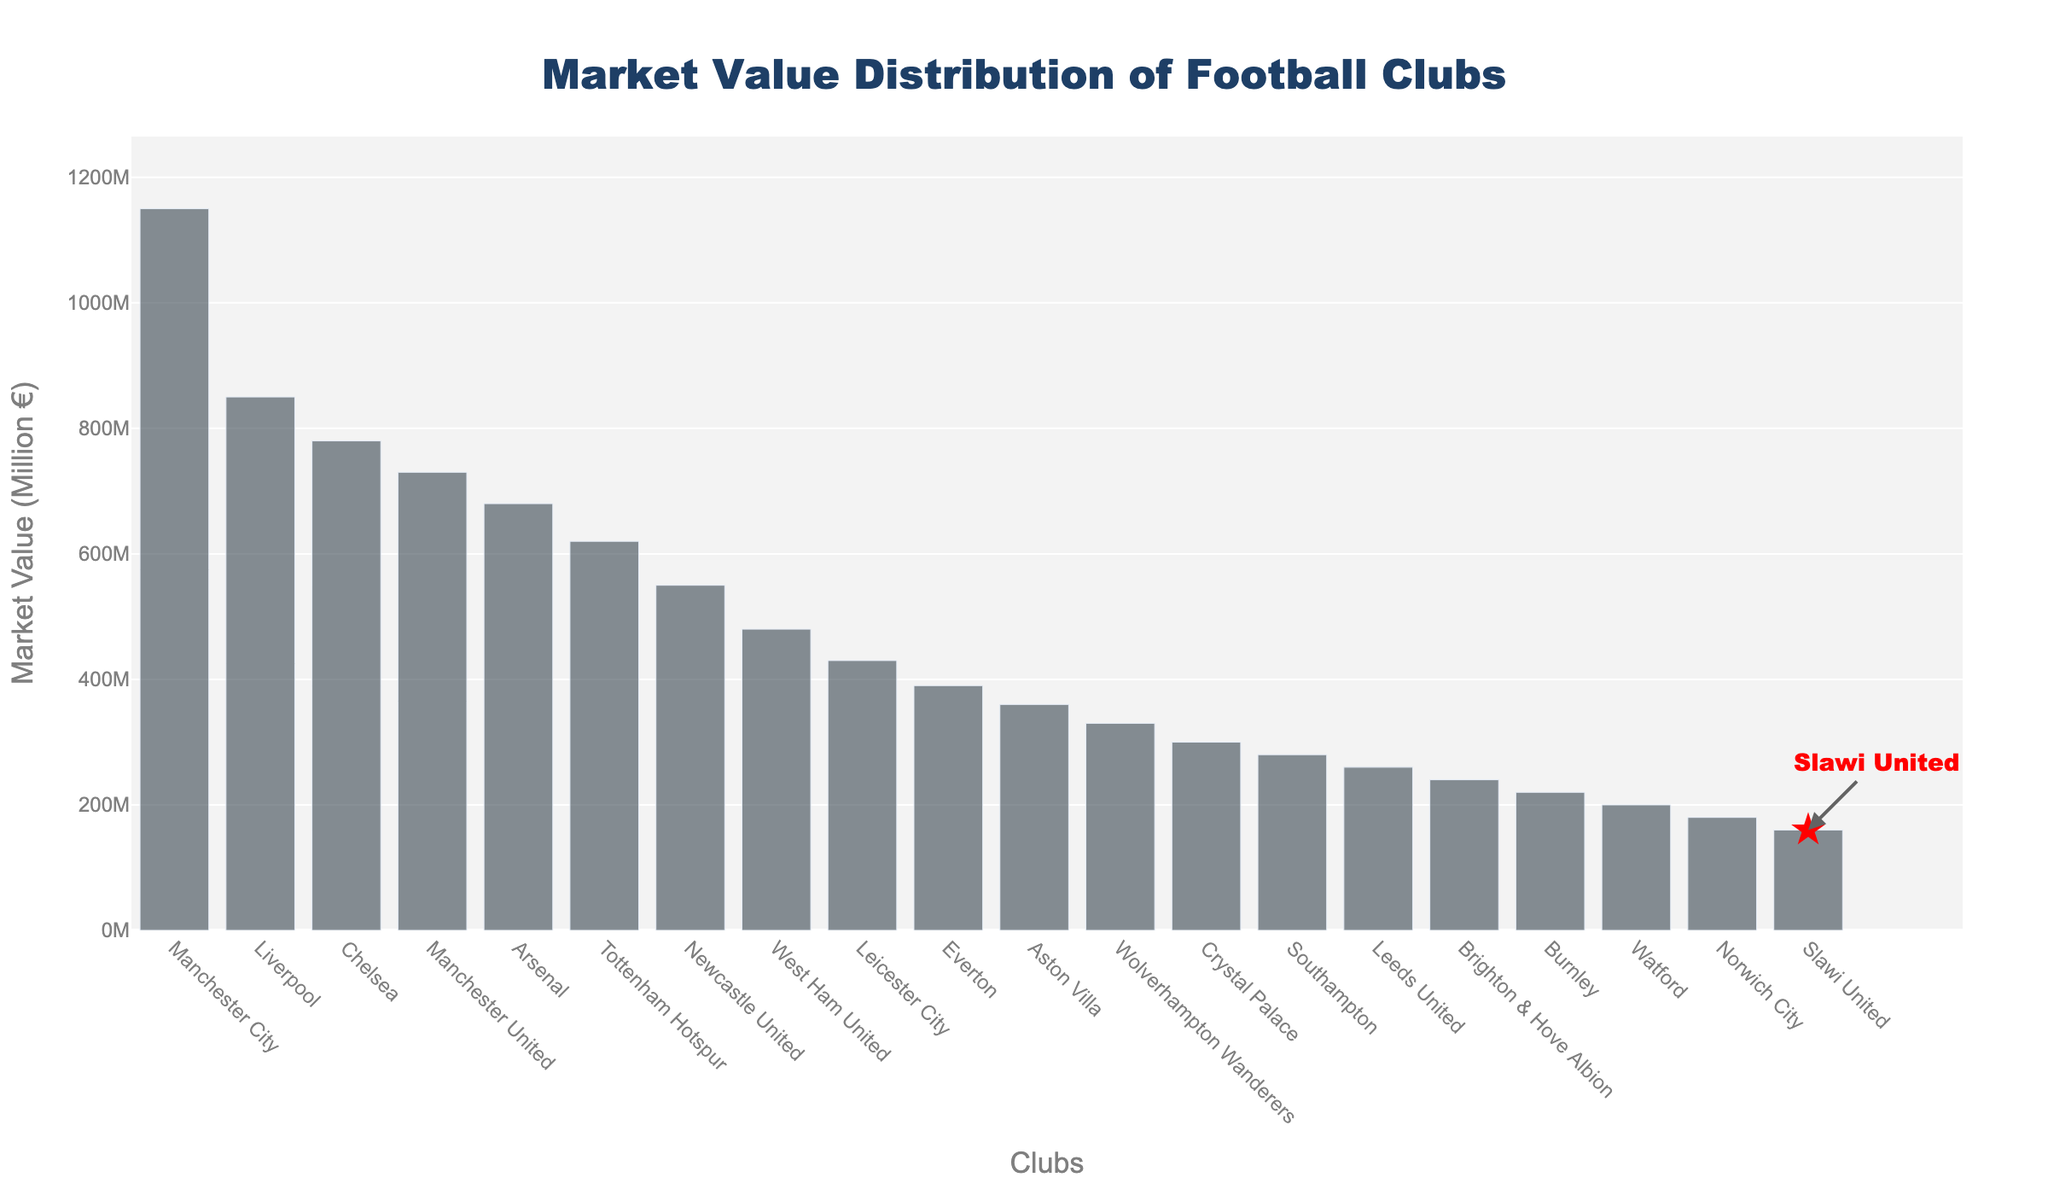Which club has the highest market value? The bar representing Manchester City is the tallest, thus it signifies the highest market value.
Answer: Manchester City What is the market value of Slawi United? In the plot, Slawi United is highlighted with a red star marker. Its corresponding bar indicates the market value.
Answer: 160 million € Where does Slawi United rank in terms of market value among the clubs? By counting from the tallest bar to Slawi United's bar, we see that it is the 20th bar.
Answer: 20th How much higher is Manchester City's market value compared to Slawi United's? Subtract Slawi United's market value (160) from Manchester City's market value (1150).
Answer: 990 million € Which clubs have market values greater than 500 million €? The bars reaching above the 500 million € mark belong to Manchester City, Liverpool, Chelsea, and Manchester United.
Answer: Manchester City, Liverpool, Chelsea, Manchester United What is the combined market value of the top 3 clubs? Add the market values for Manchester City, Liverpool, and Chelsea: 1150 + 850 + 780 = 2780 million €.
Answer: 2780 million € How does Slawi United’s market value compare to Norwich City’s market value? Compare the heights of the bar for Slawi United (160 million €) and Norwich City (180 million €).
Answer: Lower If the average market value of the clubs is used as a threshold, is Slawi United above or below this average? Calculate the average by summing all market values and dividing by the number of clubs, then compare to Slawi United's market value. Sum of all market values is (1150 + 850 + ... + 160 = 8980 million €), divided by 20 clubs = 449 million €.
Answer: Below How much less is Slawi United's market value than the league's average market value? Subtract Slawi United's market value (160 million €) from the average market value (449 million €).
Answer: 289 million € Which clubs are within 50 million € of Slawi United's market value? Identify the clubs whose bars are between 110 million € and 210 million €. Watford (200 million €) and Norwich City (180 million €) fit this criteria.
Answer: Watford, Norwich City 